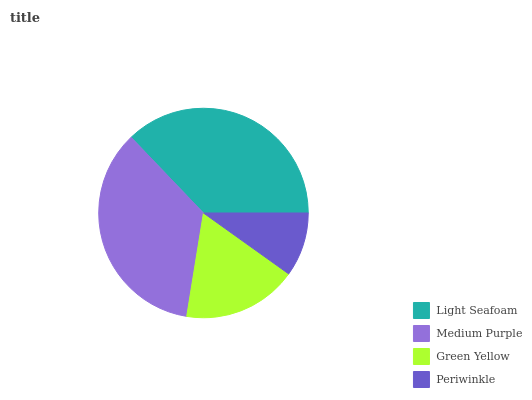Is Periwinkle the minimum?
Answer yes or no. Yes. Is Light Seafoam the maximum?
Answer yes or no. Yes. Is Medium Purple the minimum?
Answer yes or no. No. Is Medium Purple the maximum?
Answer yes or no. No. Is Light Seafoam greater than Medium Purple?
Answer yes or no. Yes. Is Medium Purple less than Light Seafoam?
Answer yes or no. Yes. Is Medium Purple greater than Light Seafoam?
Answer yes or no. No. Is Light Seafoam less than Medium Purple?
Answer yes or no. No. Is Medium Purple the high median?
Answer yes or no. Yes. Is Green Yellow the low median?
Answer yes or no. Yes. Is Light Seafoam the high median?
Answer yes or no. No. Is Medium Purple the low median?
Answer yes or no. No. 